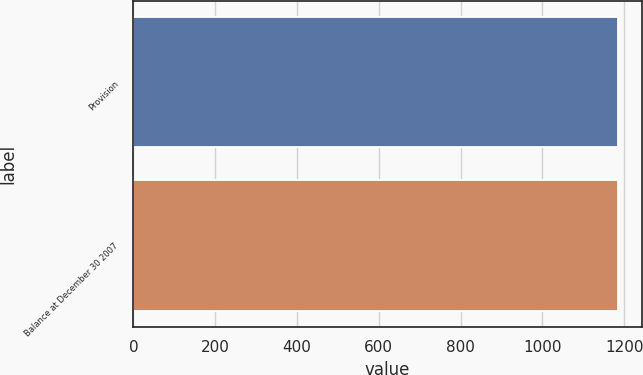Convert chart. <chart><loc_0><loc_0><loc_500><loc_500><bar_chart><fcel>Provision<fcel>Balance at December 30 2007<nl><fcel>1184<fcel>1184.1<nl></chart> 